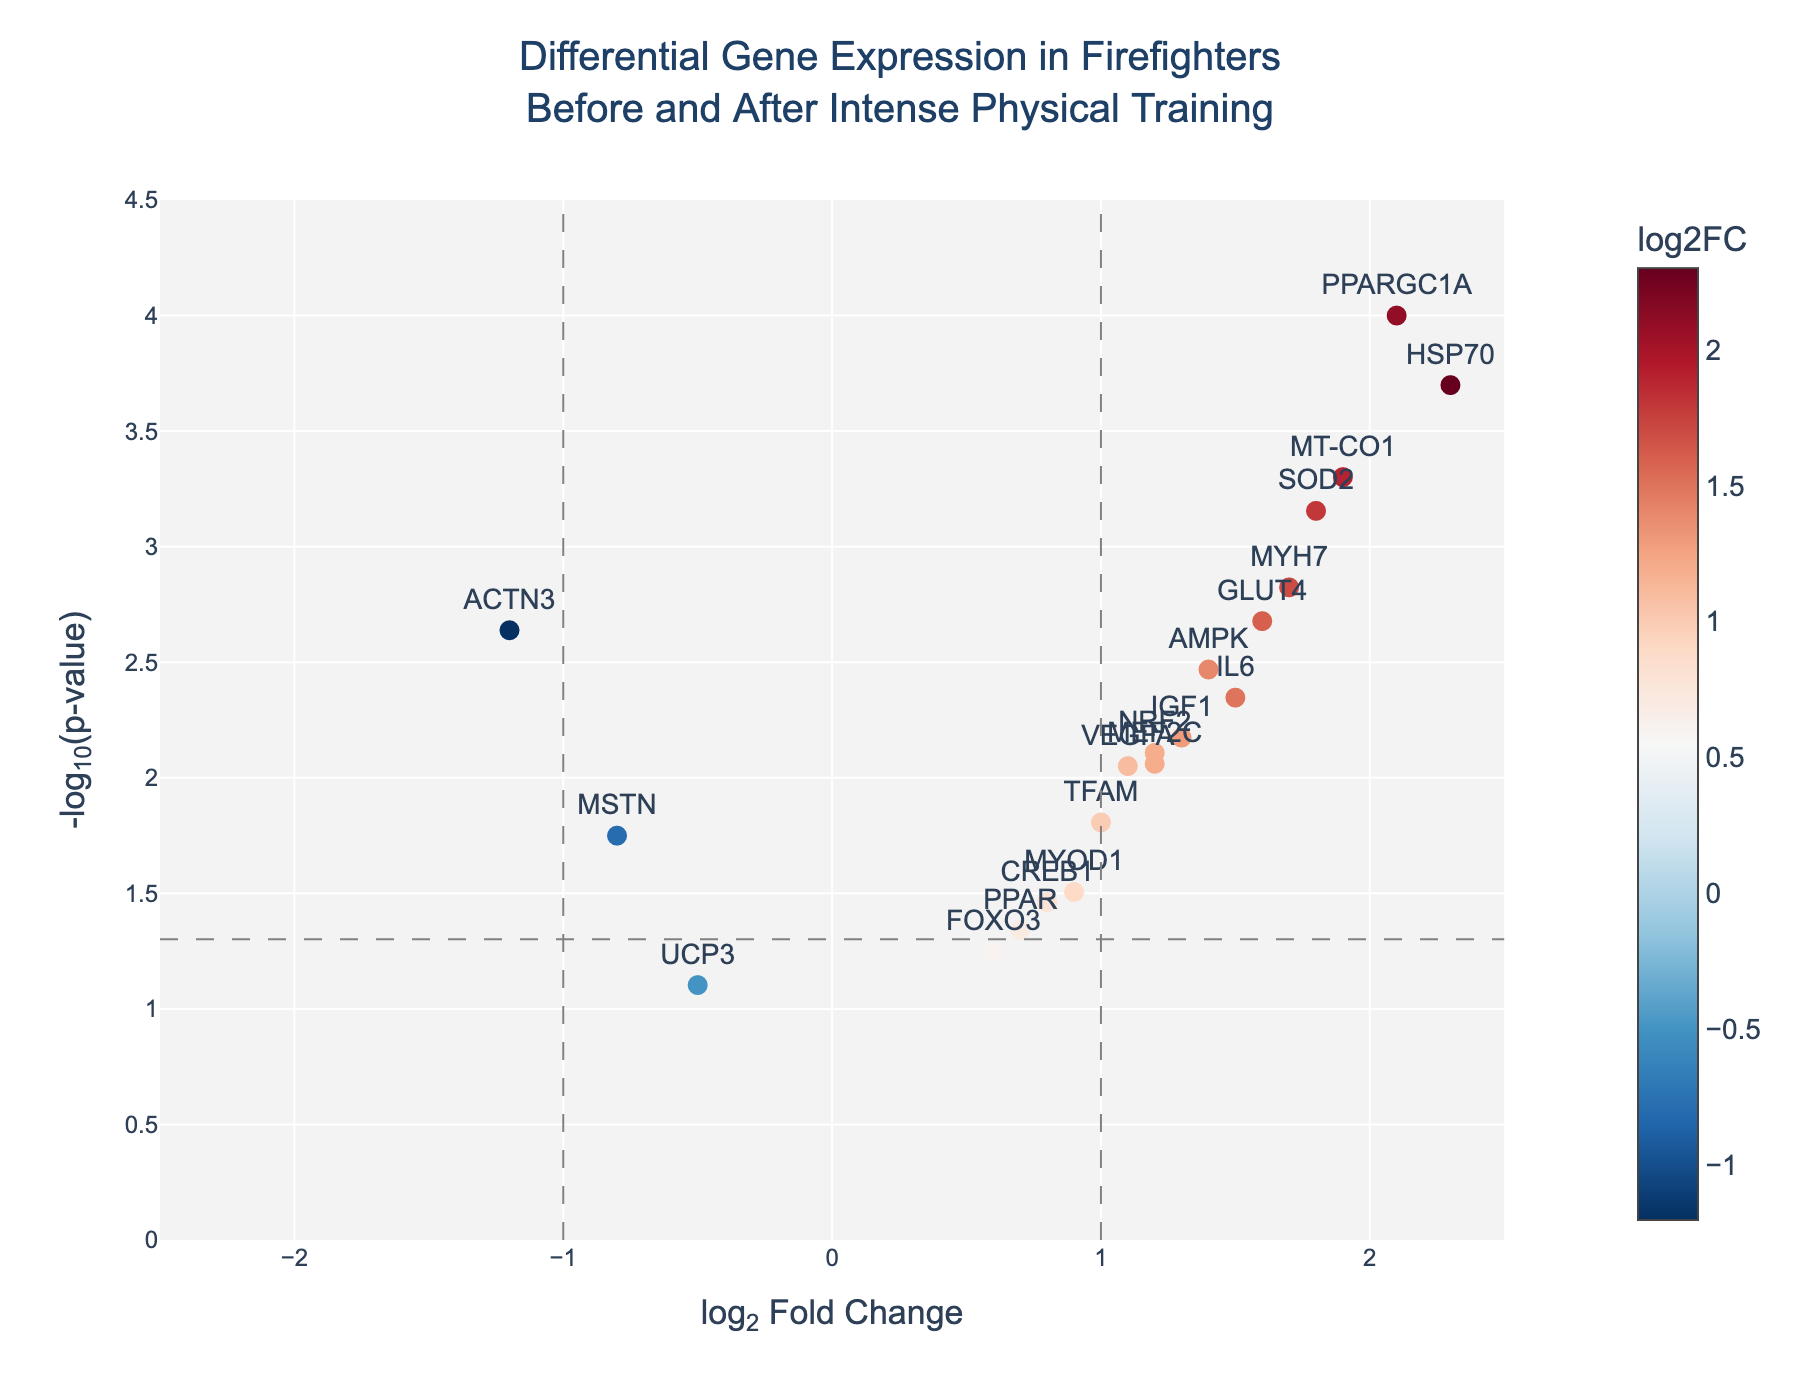What's the title of the plot? The title of the plot is typically found at the top of the plot area, usually larger and in a different font than the rest of the text. The title for this specific plot reads "Differential Gene Expression in Firefighters Before and After Intense Physical Training".
Answer: Differential Gene Expression in Firefighters Before and After Intense Physical Training What do the horizontal and vertical lines on the plot represent? The horizontal line represents the significance threshold at p-value = 0.05, often used to highlight significantly differentially expressed genes. The vertical lines at log2FoldChange = -1 and 1 indicate thresholds for biologically meaningful changes in expression levels.
Answer: Significance threshold and log2FoldChange thresholds How is the color of the data points determined? The color of the data points is determined by their log2FoldChange value, with a color scale (RdBu) showing a gradient where one end is likely for downregulated genes (negative fold change) and the other for upregulated genes (positive fold change).
Answer: log2FoldChange value Which gene has the highest log2 fold change? To identify the gene with the highest log2 fold change, look at the x-axis of the plot and find the gene label positioned furthest to the right. In this case, the gene "HSP70" has the highest log2 fold change of 2.3.
Answer: HSP70 Which gene has the highest statistical significance? The gene with the highest statistical significance will have the highest -log10(p-value), which translates to the highest point along the y-axis. "PPARGC1A" has the highest -log10(p-value).
Answer: PPARGC1A How many genes have a log2 fold change greater than 1? To determine this, count the number of gene labels that fall to the right of the vertical line at log2FoldChange = 1. The genes "PPARGC1A," "HSP70," "SOD2," "MYH7," "MT-CO1," and "GLUT4" fall into this category.
Answer: 6 Which genes are likely upregulated and related to muscle endurance and recovery? Likely upregulated genes are those with a positive log2FoldChange value. For muscle endurance and recovery, genes such as "PPARGC1A," "IL6," "HSP70," "VEGFA," "MYOD1," "SOD2," and "MYH7" fall into this category based on their known functions.
Answer: PPARGC1A, IL6, HSP70, VEGFA, MYOD1, SOD2, MYH7 Which muscle-related gene has the least change in expression but is still significant? To find this, locate the gene with a relatively small log2FoldChange (close to zero) but a high -log10(p-value). "MYOD1" has a log2FoldChange of 0.9 and a p-value of 0.0312, making it less changed but still significant.
Answer: MYOD1 How many genes are both significantly differentially expressed and upregulated? Genes considered significantly differentially expressed typically require a p-value < 0.05 (above the horizontal line) and an upregulated status with log2FoldChange > 0 (to the right of the center vertical line). Count these genes to find there are 11 such genes: "PPARGC1A," "IL6," HSP70," "VEGFA," "SOD2," "IGF1," "MYH7," "AMPK," "NRF2," "GLUT4," "MT-CO1," "MEF2C," and "CREB1."
Answer: 12 